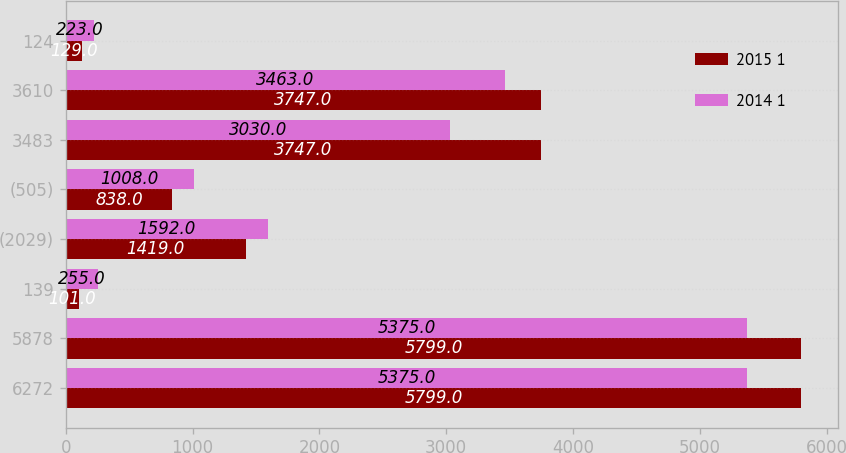<chart> <loc_0><loc_0><loc_500><loc_500><stacked_bar_chart><ecel><fcel>6272<fcel>5878<fcel>139<fcel>(2029)<fcel>(505)<fcel>3483<fcel>3610<fcel>124<nl><fcel>2015 1<fcel>5799<fcel>5799<fcel>101<fcel>1419<fcel>838<fcel>3747<fcel>3747<fcel>129<nl><fcel>2014 1<fcel>5375<fcel>5375<fcel>255<fcel>1592<fcel>1008<fcel>3030<fcel>3463<fcel>223<nl></chart> 